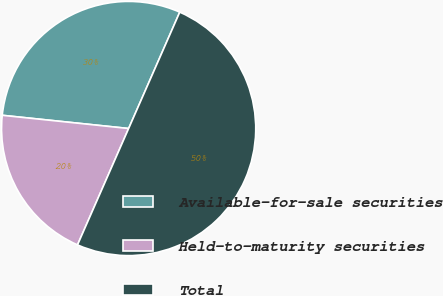Convert chart. <chart><loc_0><loc_0><loc_500><loc_500><pie_chart><fcel>Available-for-sale securities<fcel>Held-to-maturity securities<fcel>Total<nl><fcel>29.93%<fcel>20.07%<fcel>50.0%<nl></chart> 